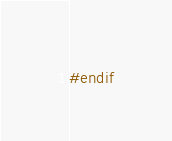Convert code to text. <code><loc_0><loc_0><loc_500><loc_500><_C++_>
#endif
</code> 